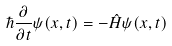<formula> <loc_0><loc_0><loc_500><loc_500>\hbar { \frac { \partial } { \partial t } } \psi ( x , t ) = - { \hat { H } } \psi ( x , t )</formula> 